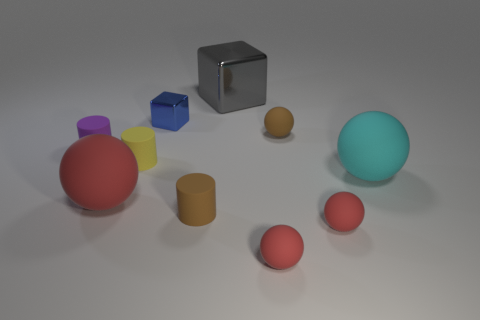Subtract all cyan blocks. How many red spheres are left? 3 Subtract all cyan matte spheres. How many spheres are left? 4 Subtract all brown balls. How many balls are left? 4 Subtract all blue balls. Subtract all purple cylinders. How many balls are left? 5 Subtract all cylinders. How many objects are left? 7 Subtract 0 green cubes. How many objects are left? 10 Subtract all brown rubber things. Subtract all small purple cylinders. How many objects are left? 7 Add 1 purple matte objects. How many purple matte objects are left? 2 Add 7 small blue shiny things. How many small blue shiny things exist? 8 